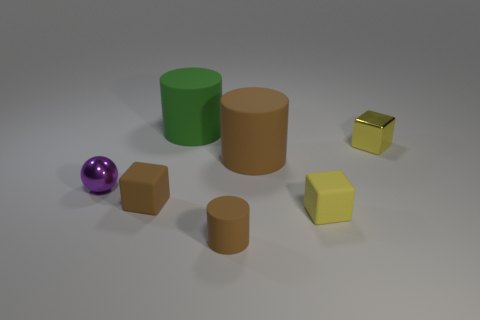Can you describe the positioning of the objects in relation to each other? Certainly! In the center, there is a purple ball. To the right of the ball, you'll see a green cylinder. Behind both the ball and the green cylinder, there's a larger brown cylinder. Slightly to the left of the ball, there is a brown cube, and in front of the cube, but slightly to the right, there lies a small yellow cube. Finally, there is a small golden cube resting behind and to the right of the small yellow one. 